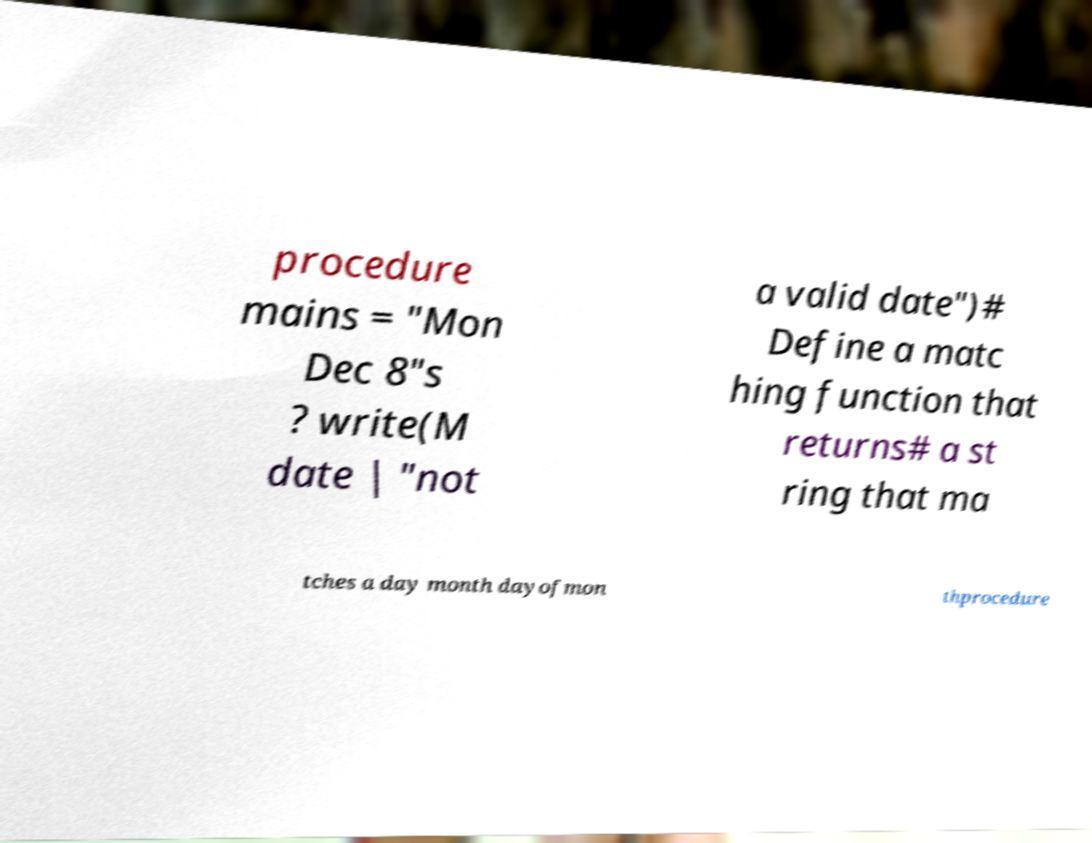Could you assist in decoding the text presented in this image and type it out clearly? procedure mains = "Mon Dec 8"s ? write(M date | "not a valid date")# Define a matc hing function that returns# a st ring that ma tches a day month dayofmon thprocedure 